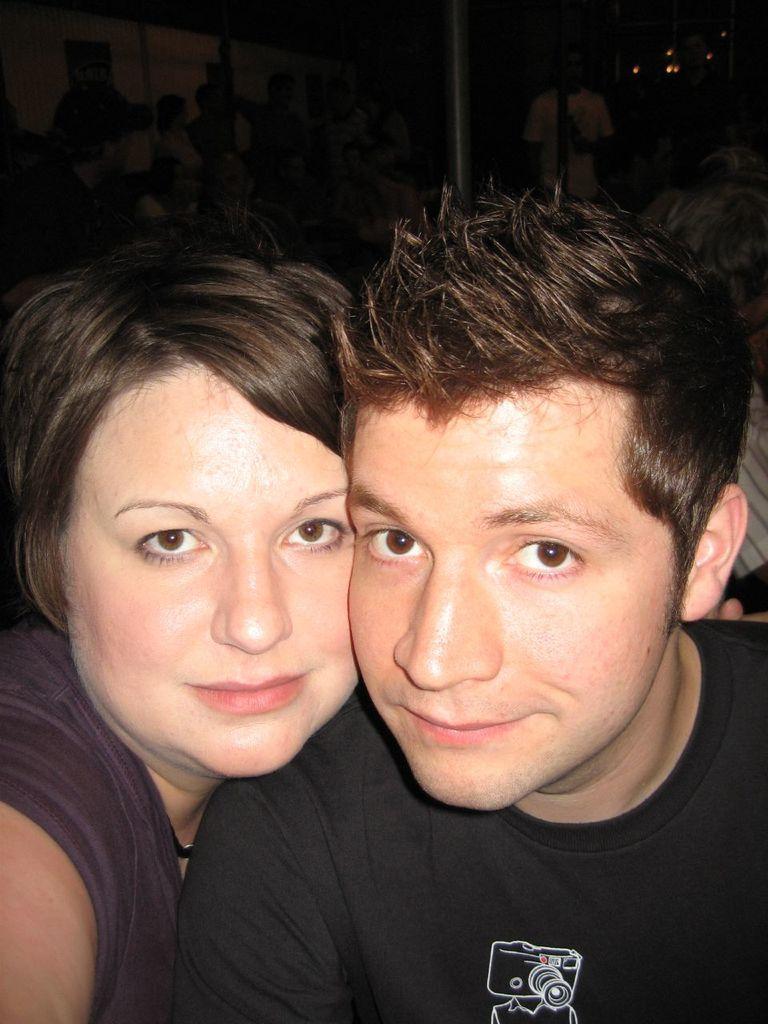Could you give a brief overview of what you see in this image? In the center of the image there are two people. In the background there is a pole and we can see people standing. 